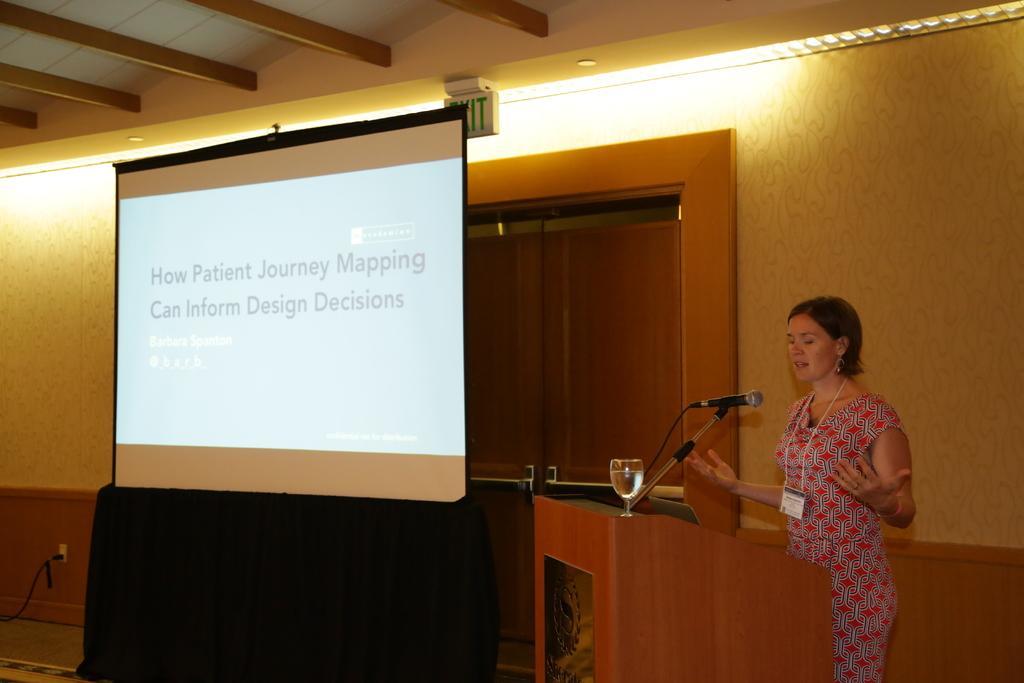Could you give a brief overview of what you see in this image? In this image, on the right, there is a lady standing and wearing an id card and we can see a glass with water and a mic with stand are on the podium. In the background, there are doors and we can see a screen and lights and a wall and we can see a switchboard and a cable. 